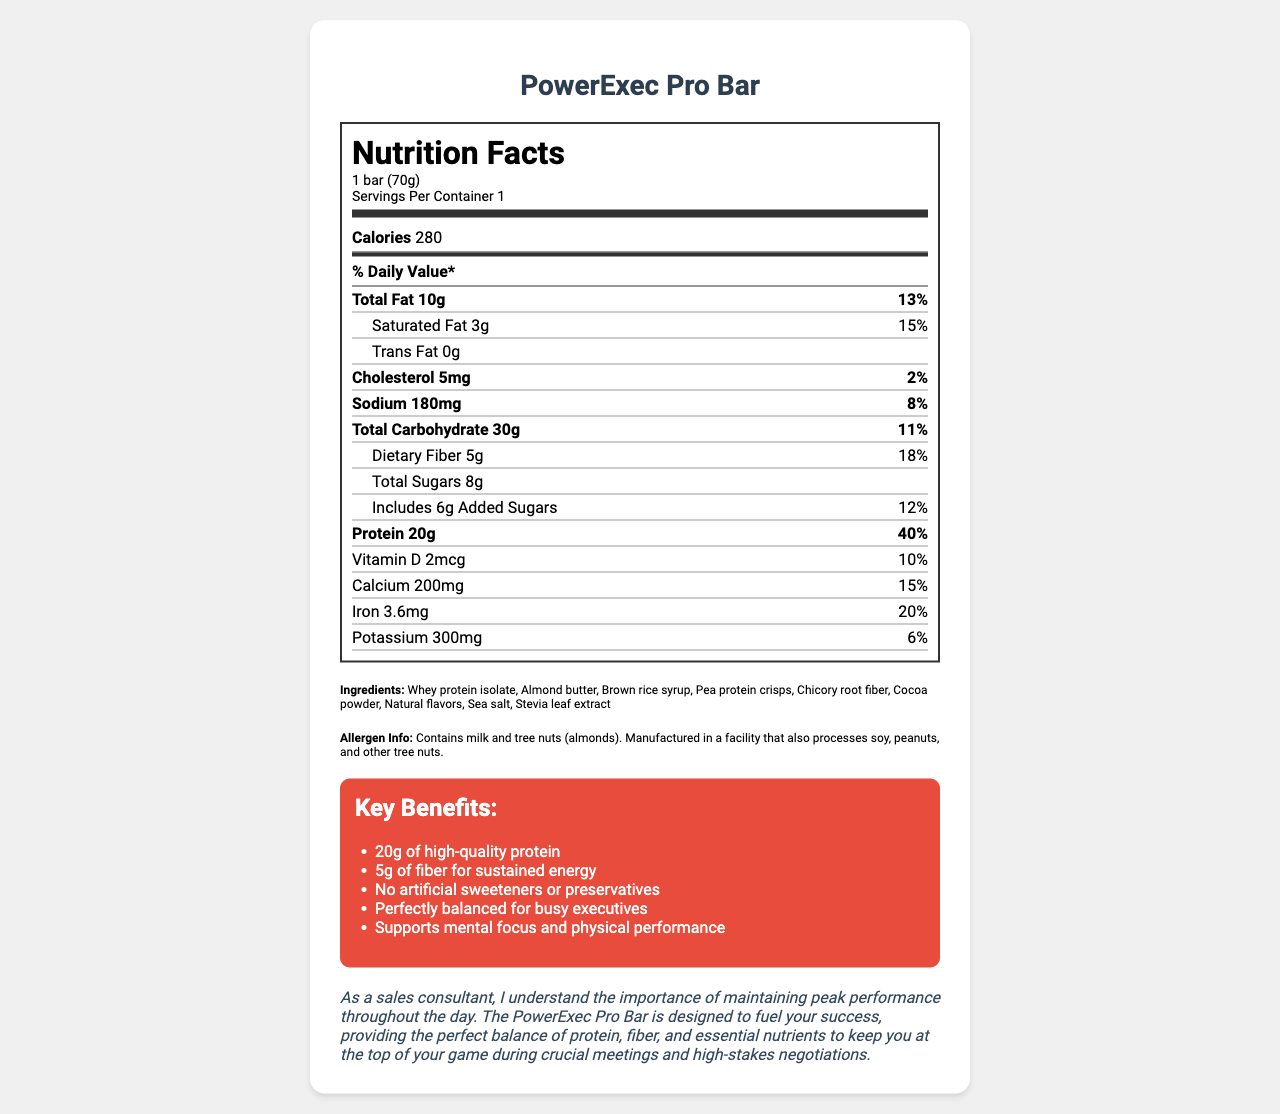what is the serving size of the PowerExec Pro Bar? The serving size is mentioned directly under the product name in the nutrition label, which states "1 bar (70g)".
Answer: 1 bar (70g) How many calories are in one serving of the PowerExec Pro Bar? The number of calories per serving is listed in the "Calories" section, which mentions 280 calories.
Answer: 280 How much protein does the PowerExec Pro Bar contain per serving? The protein amount per serving is listed in the nutrient section, which mentions 20g of protein and 40% of the daily value.
Answer: 20g What are the main allergens in the PowerExec Pro Bar? The allergen information is provided in the ingredients section, which specifies that the bar contains milk and tree nuts (almonds).
Answer: Milk and tree nuts (almonds) List at least three key benefits of the PowerExec Pro Bar. The key benefits are listed under the marketing claims section as individual points.
Answer: 20g of high-quality protein, 5g of fiber for sustained energy, No artificial sweeteners or preservatives How much dietary fiber is in the PowerExec Pro Bar, and what is its daily value percentage? The dietary fiber content is mentioned in the nutrient section as 5g, and it also provides the daily value percentage as 18%.
Answer: 5g, 18% What are the first three ingredients listed for the PowerExec Pro Bar? The ingredients list begins with these three items: whey protein isolate, almond butter, and brown rice syrup.
Answer: Whey protein isolate, Almond butter, Brown rice syrup which of the following ingredients is not found in the PowerExec Pro Bar? A. Pea protein crisps B. Corn syrup C. Chicory root fiber Corn syrup is not listed as an ingredient; the document mentions pea protein crisps and chicory root fiber.
Answer: B What is the sodium content in the PowerExec Pro Bar? A. 50mg B. 100mg C. 180mg D. 300mg The sodium content is specified as 180mg in the nutrient section.
Answer: C True or False: The PowerExec Pro Bar contains trans fat. The document explicitly states that the bar contains 0g of trans fat.
Answer: False Summarize the main idea of the PowerExec Pro Bar document. The explanation includes the primary focus of the document, detailing nutritional content, ingredients, allergens, marketing benefits, and its target audience of busy executives.
Answer: The document provides detailed nutritional information, ingredients, allergen warnings, and marketing claims for the PowerExec Pro Bar. It highlights the bar's suitability for busy executives with its high protein content, balanced nutrients, and key benefits such as sustained energy and mental focus support. What is the amount of iron in the PowerExec Pro Bar? The document states the iron content in the nutrient section, which lists 3.6mg of iron and 20% of the daily value.
Answer: 3.6mg How much Vitamin D is present in one serving of the PowerExec Pro Bar? The vitamin D amount is specified as 2mcg in the nutrients section.
Answer: 2mcg Which nutrient listed has the highest daily value percentage? The nutrient section shows that protein has the highest daily value percentage at 40%.
Answer: Protein (40%) Can the PowerExec Pro Bar be consumed by someone with a peanut allergy? Although the bar does not list peanuts as an ingredient, it is manufactured in a facility that processes peanuts. Therefore, safety cannot be determined with the provided information.
Answer: I don't know What kind of extract is used as a sweetener in the PowerExec Pro Bar? The ingredient list mentions Stevia leaf extract as a natural sweetener included in the bar.
Answer: Stevia leaf extract 